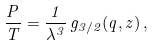<formula> <loc_0><loc_0><loc_500><loc_500>\frac { P } { T } = \frac { 1 } { \lambda ^ { 3 } } \, g _ { 3 / 2 } ( q , z ) \, ,</formula> 